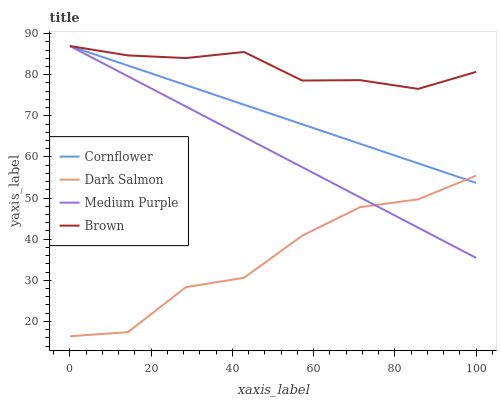Does Dark Salmon have the minimum area under the curve?
Answer yes or no. Yes. Does Brown have the maximum area under the curve?
Answer yes or no. Yes. Does Cornflower have the minimum area under the curve?
Answer yes or no. No. Does Cornflower have the maximum area under the curve?
Answer yes or no. No. Is Cornflower the smoothest?
Answer yes or no. Yes. Is Dark Salmon the roughest?
Answer yes or no. Yes. Is Dark Salmon the smoothest?
Answer yes or no. No. Is Cornflower the roughest?
Answer yes or no. No. Does Dark Salmon have the lowest value?
Answer yes or no. Yes. Does Cornflower have the lowest value?
Answer yes or no. No. Does Brown have the highest value?
Answer yes or no. Yes. Does Dark Salmon have the highest value?
Answer yes or no. No. Is Dark Salmon less than Brown?
Answer yes or no. Yes. Is Brown greater than Dark Salmon?
Answer yes or no. Yes. Does Medium Purple intersect Dark Salmon?
Answer yes or no. Yes. Is Medium Purple less than Dark Salmon?
Answer yes or no. No. Is Medium Purple greater than Dark Salmon?
Answer yes or no. No. Does Dark Salmon intersect Brown?
Answer yes or no. No. 